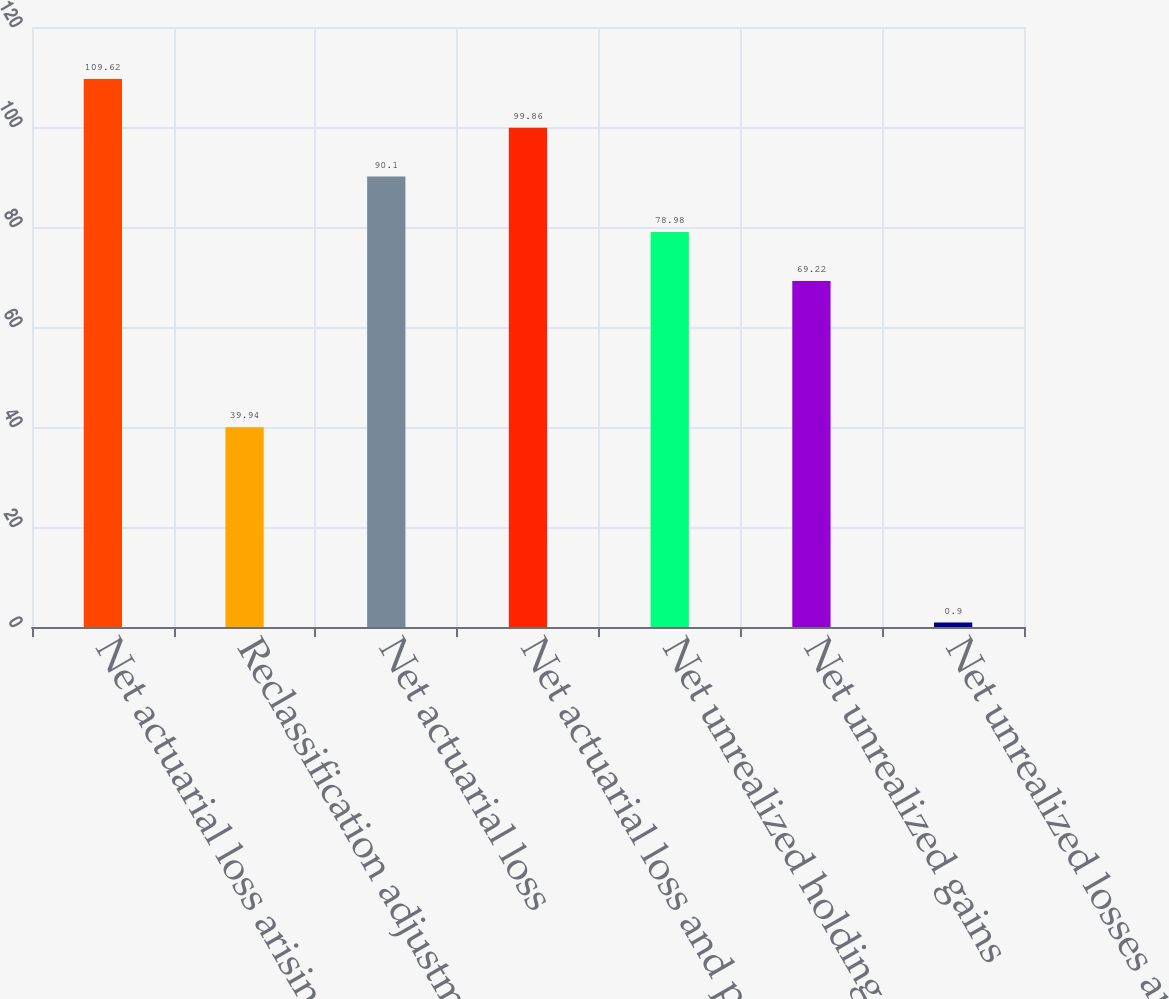<chart> <loc_0><loc_0><loc_500><loc_500><bar_chart><fcel>Net actuarial loss arising<fcel>Reclassification adjustment<fcel>Net actuarial loss<fcel>Net actuarial loss and prior<fcel>Net unrealized holding gains<fcel>Net unrealized gains<fcel>Net unrealized losses arising<nl><fcel>109.62<fcel>39.94<fcel>90.1<fcel>99.86<fcel>78.98<fcel>69.22<fcel>0.9<nl></chart> 